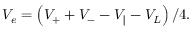<formula> <loc_0><loc_0><loc_500><loc_500>V _ { e } = \left ( V _ { + } + V _ { - } - V _ { \| } - V _ { L } \right ) / 4 .</formula> 